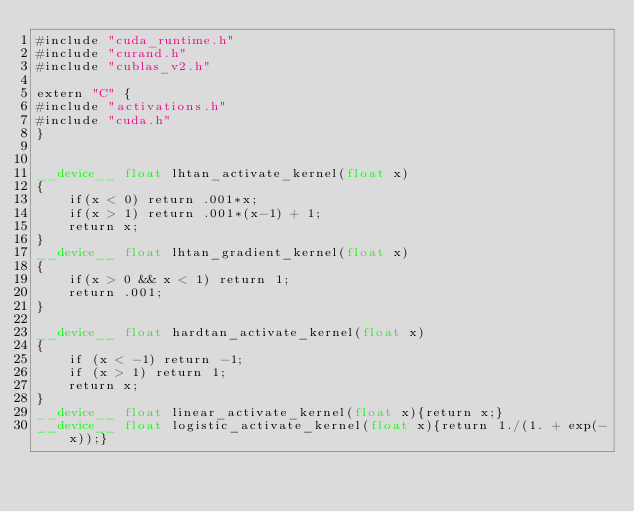Convert code to text. <code><loc_0><loc_0><loc_500><loc_500><_Cuda_>#include "cuda_runtime.h"
#include "curand.h"
#include "cublas_v2.h"

extern "C" {
#include "activations.h"
#include "cuda.h"
}


__device__ float lhtan_activate_kernel(float x)
{
    if(x < 0) return .001*x;
    if(x > 1) return .001*(x-1) + 1;
    return x;
}
__device__ float lhtan_gradient_kernel(float x)
{
    if(x > 0 && x < 1) return 1;
    return .001;
}

__device__ float hardtan_activate_kernel(float x)
{
    if (x < -1) return -1;
    if (x > 1) return 1;
    return x;
}
__device__ float linear_activate_kernel(float x){return x;}
__device__ float logistic_activate_kernel(float x){return 1./(1. + exp(-x));}</code> 